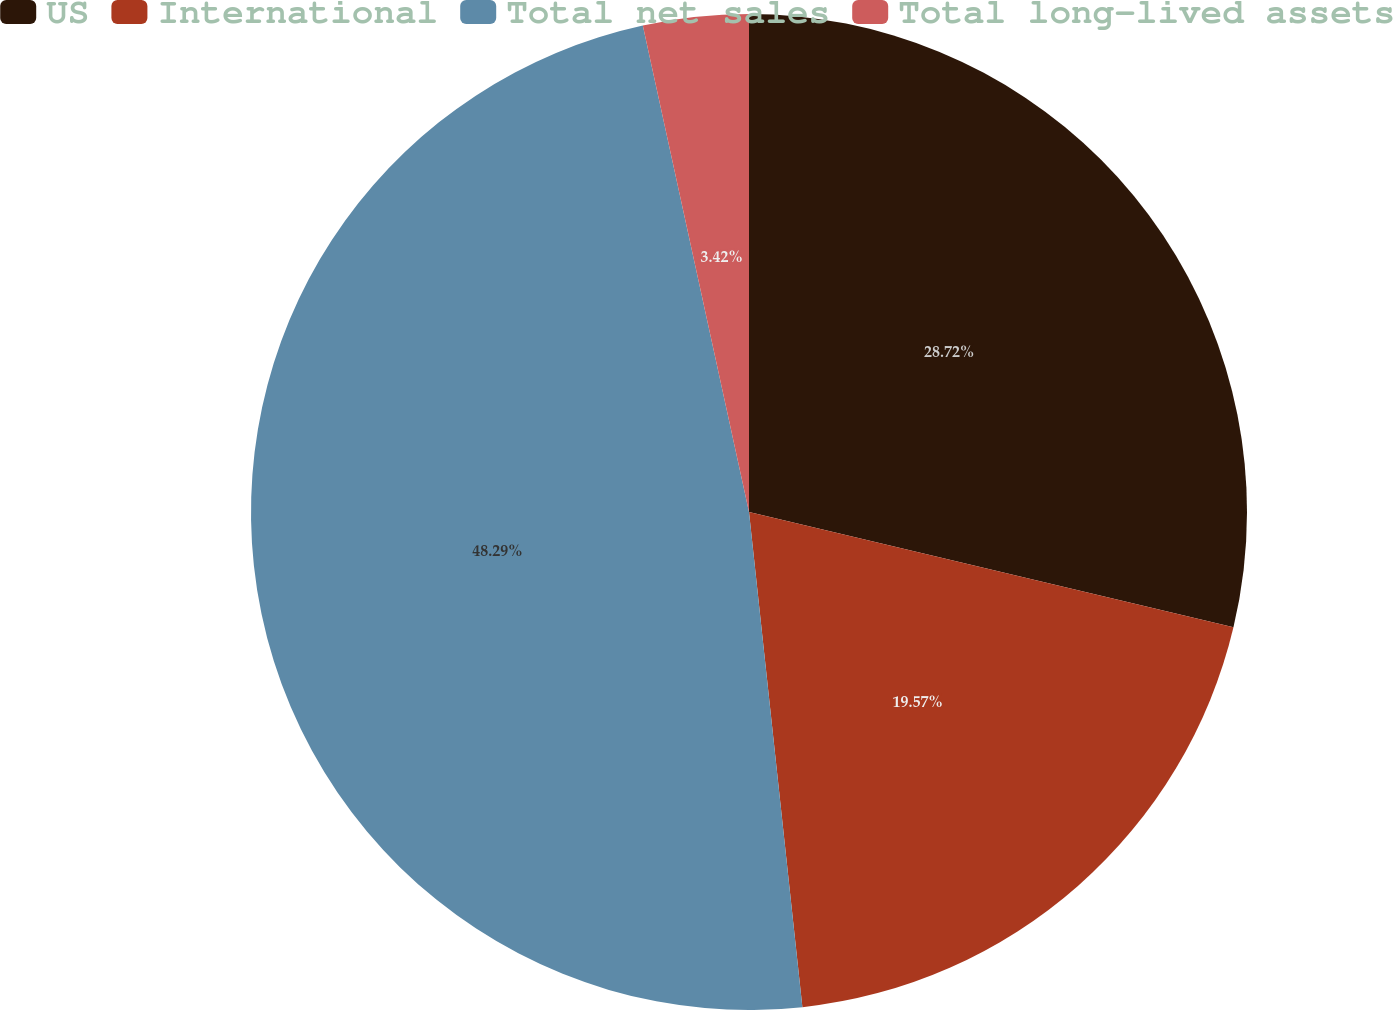Convert chart to OTSL. <chart><loc_0><loc_0><loc_500><loc_500><pie_chart><fcel>US<fcel>International<fcel>Total net sales<fcel>Total long-lived assets<nl><fcel>28.72%<fcel>19.57%<fcel>48.29%<fcel>3.42%<nl></chart> 